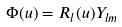Convert formula to latex. <formula><loc_0><loc_0><loc_500><loc_500>\Phi ( u ) = R _ { l } ( u ) Y _ { l m }</formula> 